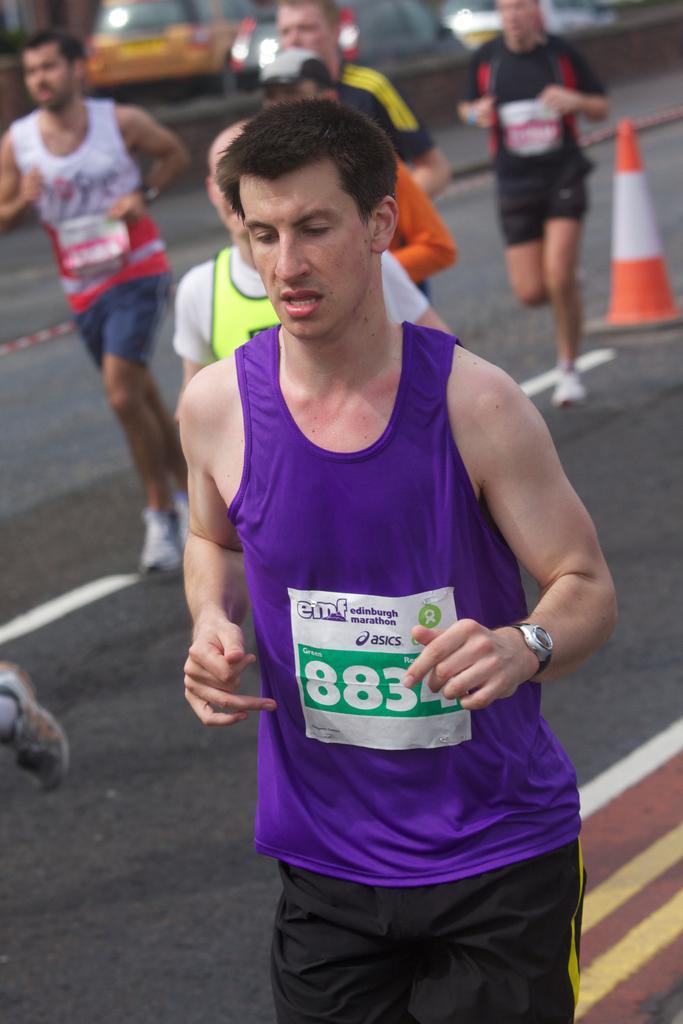How would you summarize this image in a sentence or two? In this image there are persons running and in the background there are cars, there is a stand which is red and white in colour and there is a wall. 